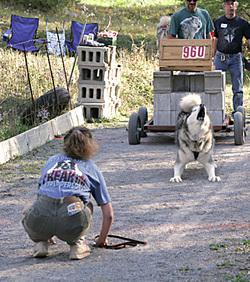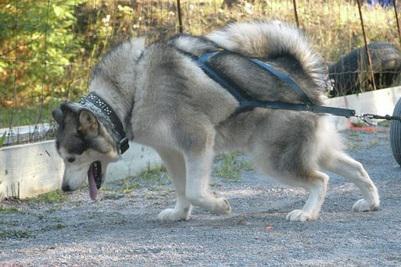The first image is the image on the left, the second image is the image on the right. Analyze the images presented: Is the assertion "One image shows a leftward-turned dog in a harness leaning forward in profile as it strains to pull something that is out of sight, and the other image shows a dog standing on all fours with its head raised and mouth open." valid? Answer yes or no. Yes. The first image is the image on the left, the second image is the image on the right. Assess this claim about the two images: "A dog is pulling a cart using only its hind legs in one of the pictures.". Correct or not? Answer yes or no. No. 